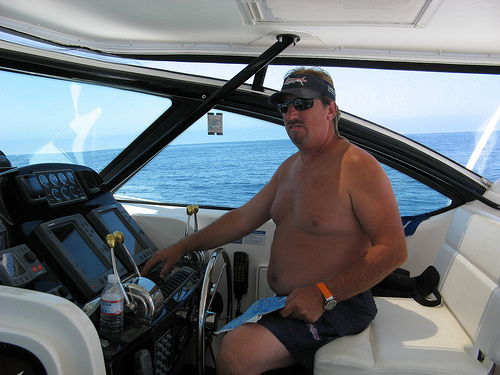<image>
Is there a man in the water? No. The man is not contained within the water. These objects have a different spatial relationship. 